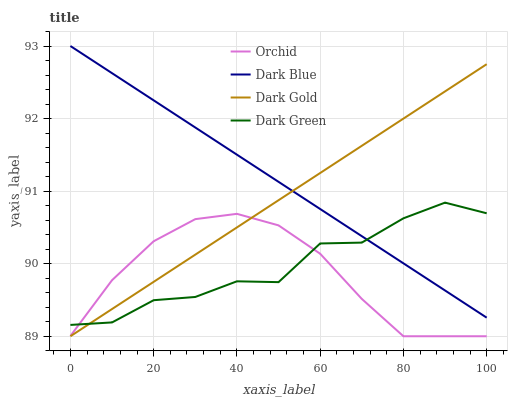Does Dark Gold have the minimum area under the curve?
Answer yes or no. No. Does Dark Gold have the maximum area under the curve?
Answer yes or no. No. Is Dark Green the smoothest?
Answer yes or no. No. Is Dark Gold the roughest?
Answer yes or no. No. Does Dark Green have the lowest value?
Answer yes or no. No. Does Dark Gold have the highest value?
Answer yes or no. No. Is Orchid less than Dark Blue?
Answer yes or no. Yes. Is Dark Blue greater than Orchid?
Answer yes or no. Yes. Does Orchid intersect Dark Blue?
Answer yes or no. No. 